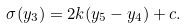Convert formula to latex. <formula><loc_0><loc_0><loc_500><loc_500>\sigma ( y _ { 3 } ) = 2 k ( y _ { 5 } - y _ { 4 } ) + c . \,</formula> 